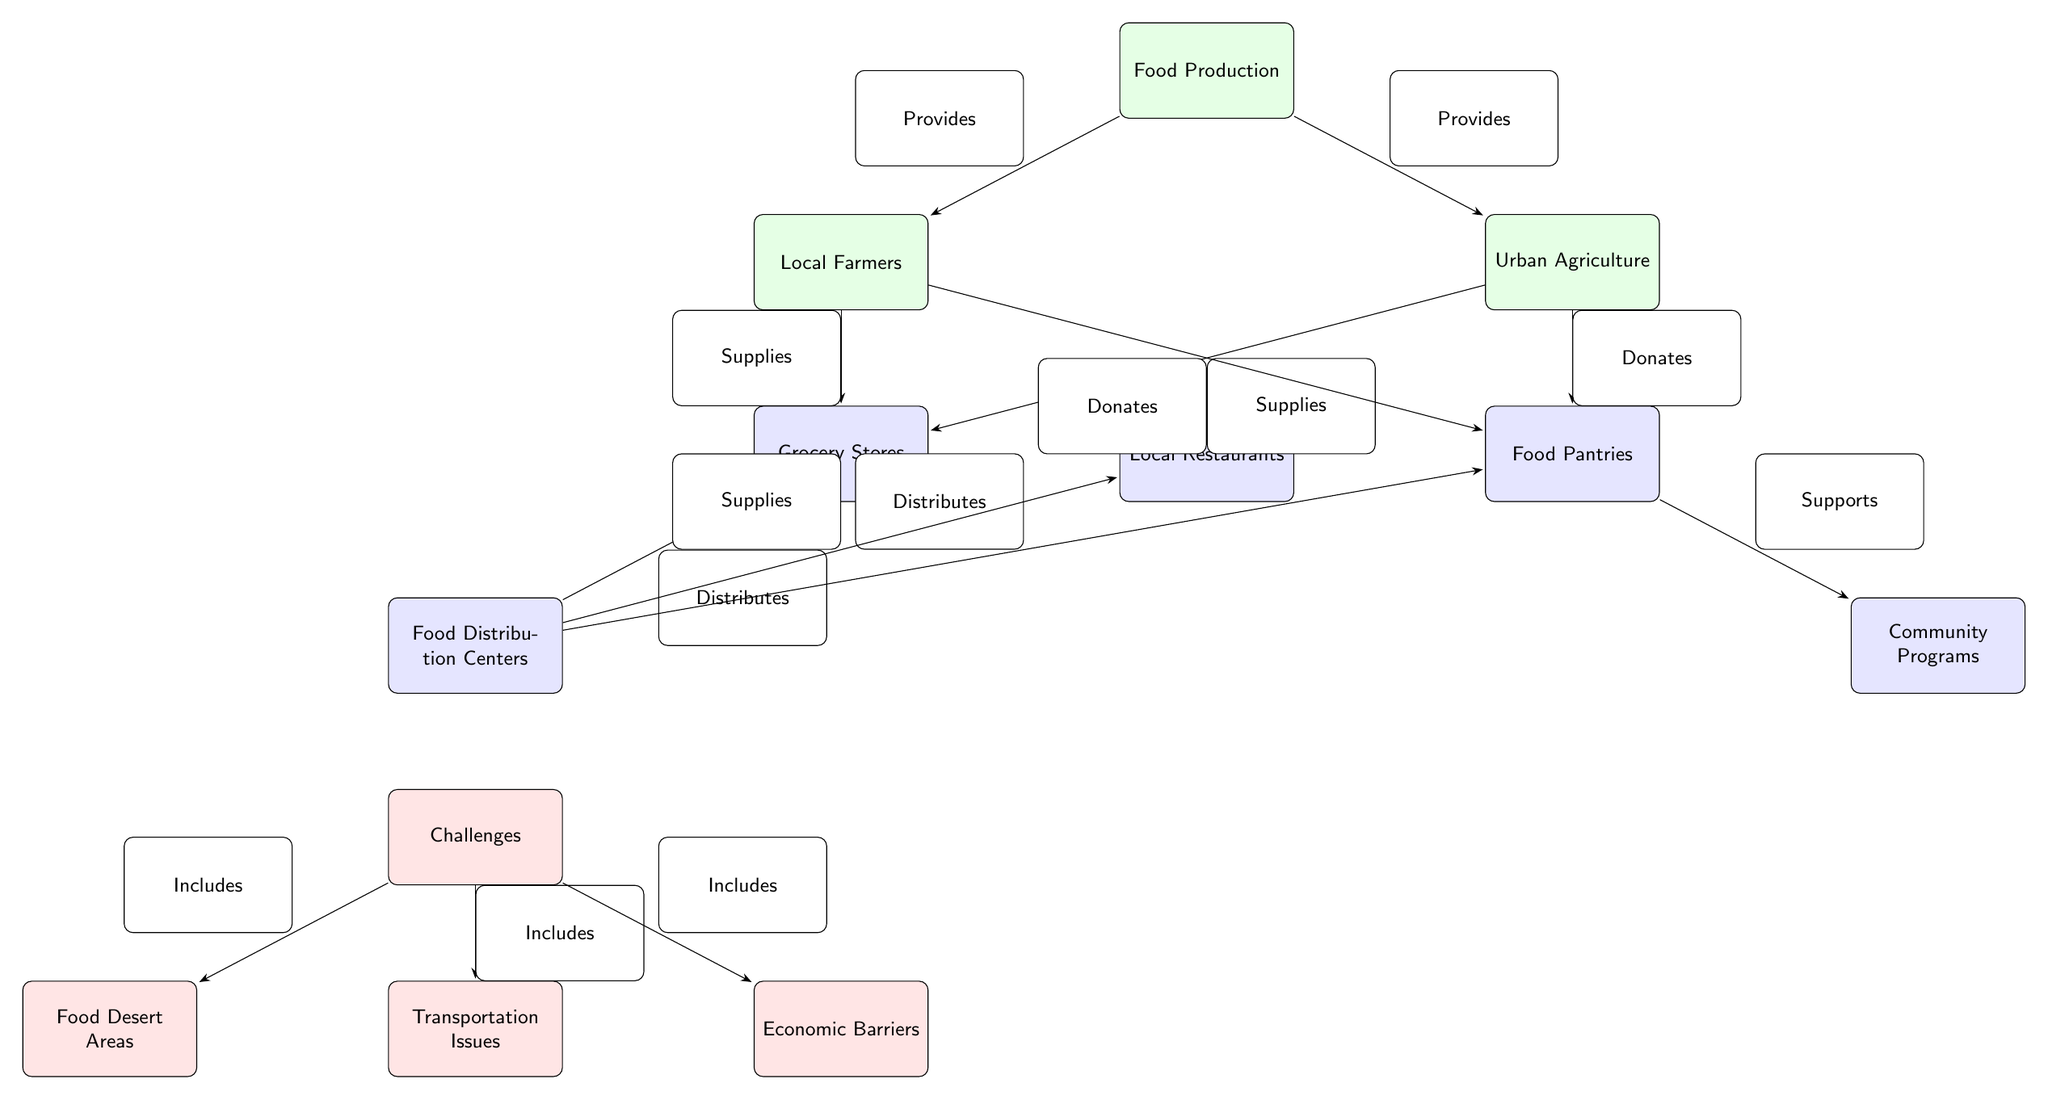What node represents local food production? The top node labeled "Food Production" indicates the overall source of food in the chain, highlighting where local food originates.
Answer: Food Production Which nodes provide supplies to grocery stores? The nodes labeled "Local Farmers" and "Urban Agriculture" both directly supply grocery stores, indicating they are sources of food that contribute to grocery store inventory.
Answer: Local Farmers, Urban Agriculture How many distribution nodes are shown in the diagram? By counting the nodes designated under the "distribution" style, there are four: "Grocery Stores," "Food Pantries," "Food Distribution Centers," and "Local Restaurants."
Answer: Four What is one of the major challenges to food access highlighted in the diagram? The diagram lists several challenges, and one significant example is "Food Desert Areas," which reflects regions lacking access to affordable and nutritious food.
Answer: Food Desert Areas Which two nodes donate food to food pantries? The nodes "Local Farmers" and "Urban Agriculture" are both indicated as sources that donate food directly to "Food Pantries" represented in the diagram.
Answer: Local Farmers, Urban Agriculture What relationship exists between food distribution centers and grocery stores? The edge labeled "Distributes" indicates that food distribution centers actively distribute food to grocery stores, outlining their role in the food supply chain.
Answer: Distributes What is indicated as an economic barrier in the diagram? The node "Economic Barriers" specifies that financial challenges are a significant obstacle affecting access to nutritious food in underserved communities.
Answer: Economic Barriers Which node is connected to community programs? The connection shows that "Food Pantries" support "Community Programs," indicating how food pantries play a role in community food security efforts.
Answer: Food Pantries What type of node is "Transportation Issues"? "Transportation Issues" is categorized under a challenge style, highlighting it as a barrier affecting accessibility to nutritious food for the community.
Answer: Challenge 